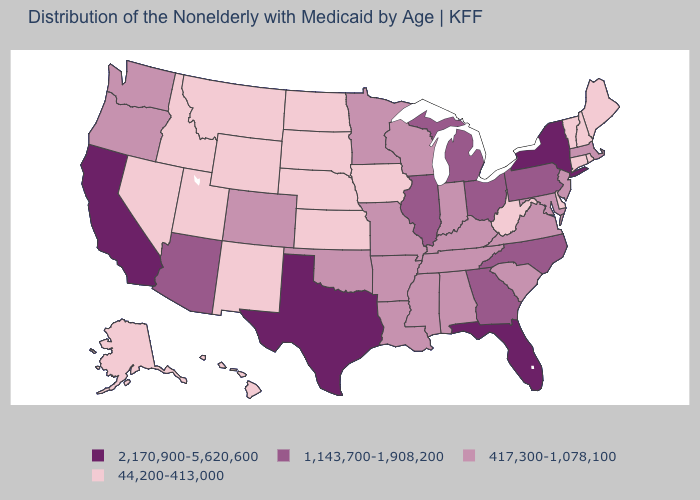Among the states that border Kansas , which have the highest value?
Answer briefly. Colorado, Missouri, Oklahoma. Which states have the highest value in the USA?
Be succinct. California, Florida, New York, Texas. Among the states that border Pennsylvania , which have the highest value?
Short answer required. New York. What is the value of Tennessee?
Write a very short answer. 417,300-1,078,100. Does Kansas have the lowest value in the MidWest?
Keep it brief. Yes. What is the lowest value in the West?
Give a very brief answer. 44,200-413,000. Name the states that have a value in the range 44,200-413,000?
Concise answer only. Alaska, Connecticut, Delaware, Hawaii, Idaho, Iowa, Kansas, Maine, Montana, Nebraska, Nevada, New Hampshire, New Mexico, North Dakota, Rhode Island, South Dakota, Utah, Vermont, West Virginia, Wyoming. Which states have the highest value in the USA?
Answer briefly. California, Florida, New York, Texas. Name the states that have a value in the range 44,200-413,000?
Keep it brief. Alaska, Connecticut, Delaware, Hawaii, Idaho, Iowa, Kansas, Maine, Montana, Nebraska, Nevada, New Hampshire, New Mexico, North Dakota, Rhode Island, South Dakota, Utah, Vermont, West Virginia, Wyoming. Which states have the highest value in the USA?
Give a very brief answer. California, Florida, New York, Texas. Does the map have missing data?
Concise answer only. No. Among the states that border North Dakota , does Montana have the highest value?
Keep it brief. No. What is the lowest value in states that border Minnesota?
Short answer required. 44,200-413,000. Among the states that border Connecticut , which have the lowest value?
Be succinct. Rhode Island. Does Nevada have the lowest value in the West?
Keep it brief. Yes. 